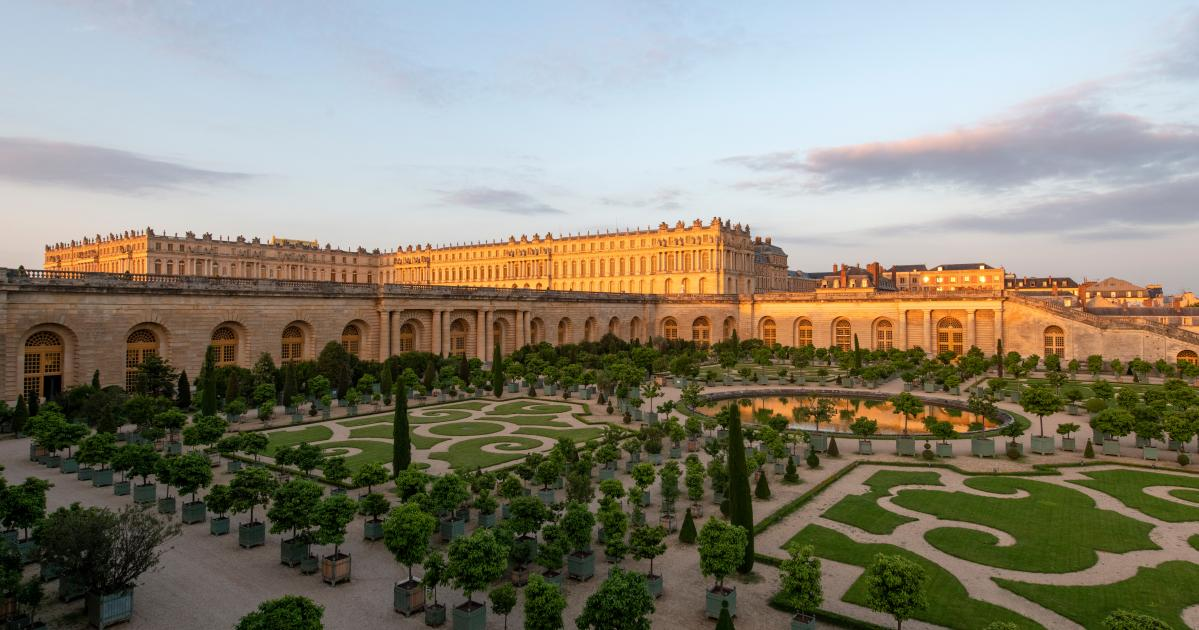Analyze the image in a comprehensive and detailed manner. The image showcases the opulent Palace of Versailles, an iconic landmark in France. Taken from a high vantage point, it offers a sweeping view of both the palace and its meticulously curated gardens. The palace itself is a grandiose, elongated rectangle, its light-hued facade adorned with countless windows, reflecting the architectural elegance of a bygone era. The gardens are a masterpiece of landscape design, featuring intricate geometric patterns etched into the greenery, with a majestic fountain serving as a focal point. The sky above is a serene blue, scattered with a few clouds, while the setting sun bathes the scene in a warm, golden glow, enhancing the overall splendor and tranquility of the moment captured. 